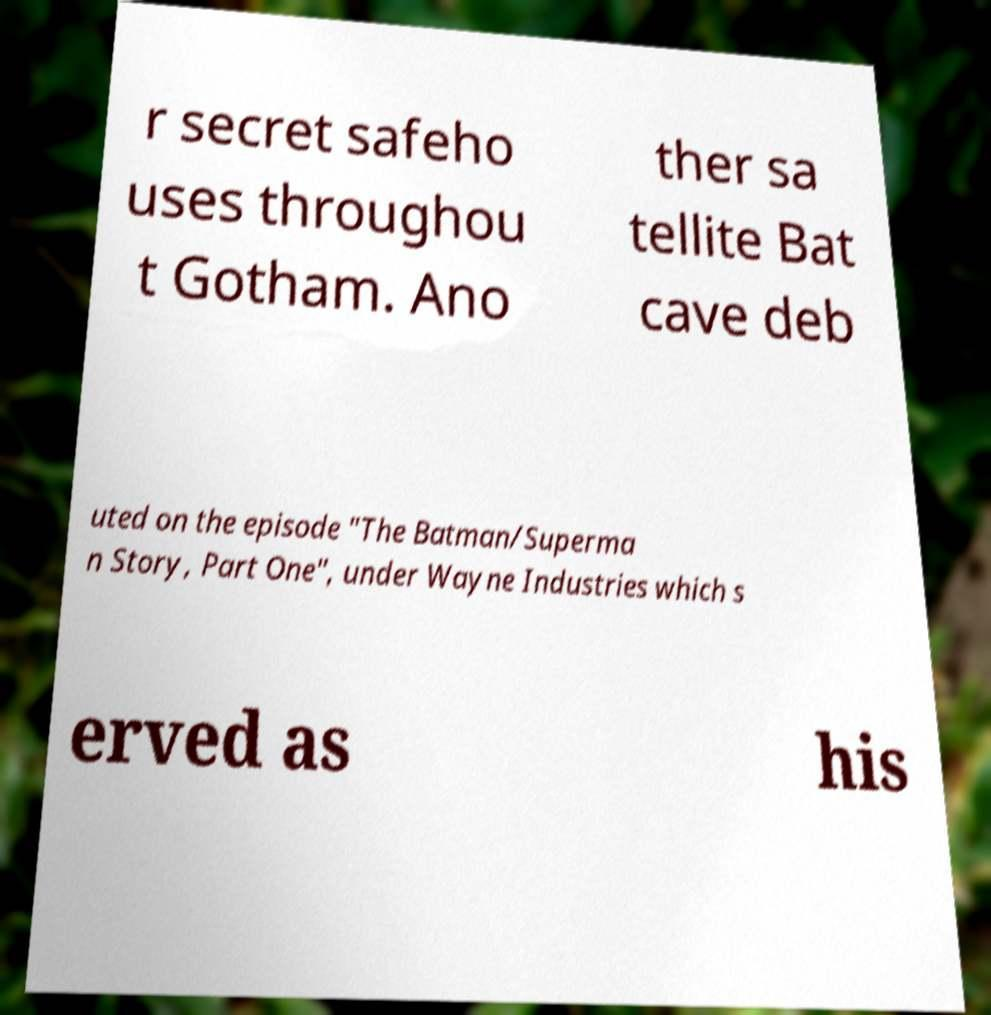Please identify and transcribe the text found in this image. r secret safeho uses throughou t Gotham. Ano ther sa tellite Bat cave deb uted on the episode "The Batman/Superma n Story, Part One", under Wayne Industries which s erved as his 